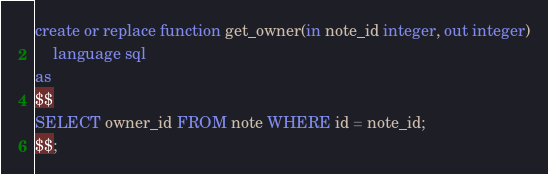<code> <loc_0><loc_0><loc_500><loc_500><_SQL_>create or replace function get_owner(in note_id integer, out integer)
    language sql
as
$$
SELECT owner_id FROM note WHERE id = note_id;
$$;</code> 